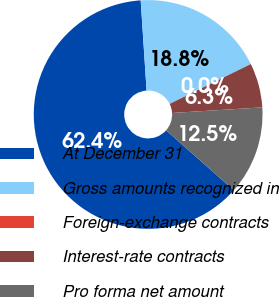Convert chart to OTSL. <chart><loc_0><loc_0><loc_500><loc_500><pie_chart><fcel>At December 31<fcel>Gross amounts recognized in<fcel>Foreign-exchange contracts<fcel>Interest-rate contracts<fcel>Pro forma net amount<nl><fcel>62.43%<fcel>18.75%<fcel>0.03%<fcel>6.27%<fcel>12.51%<nl></chart> 